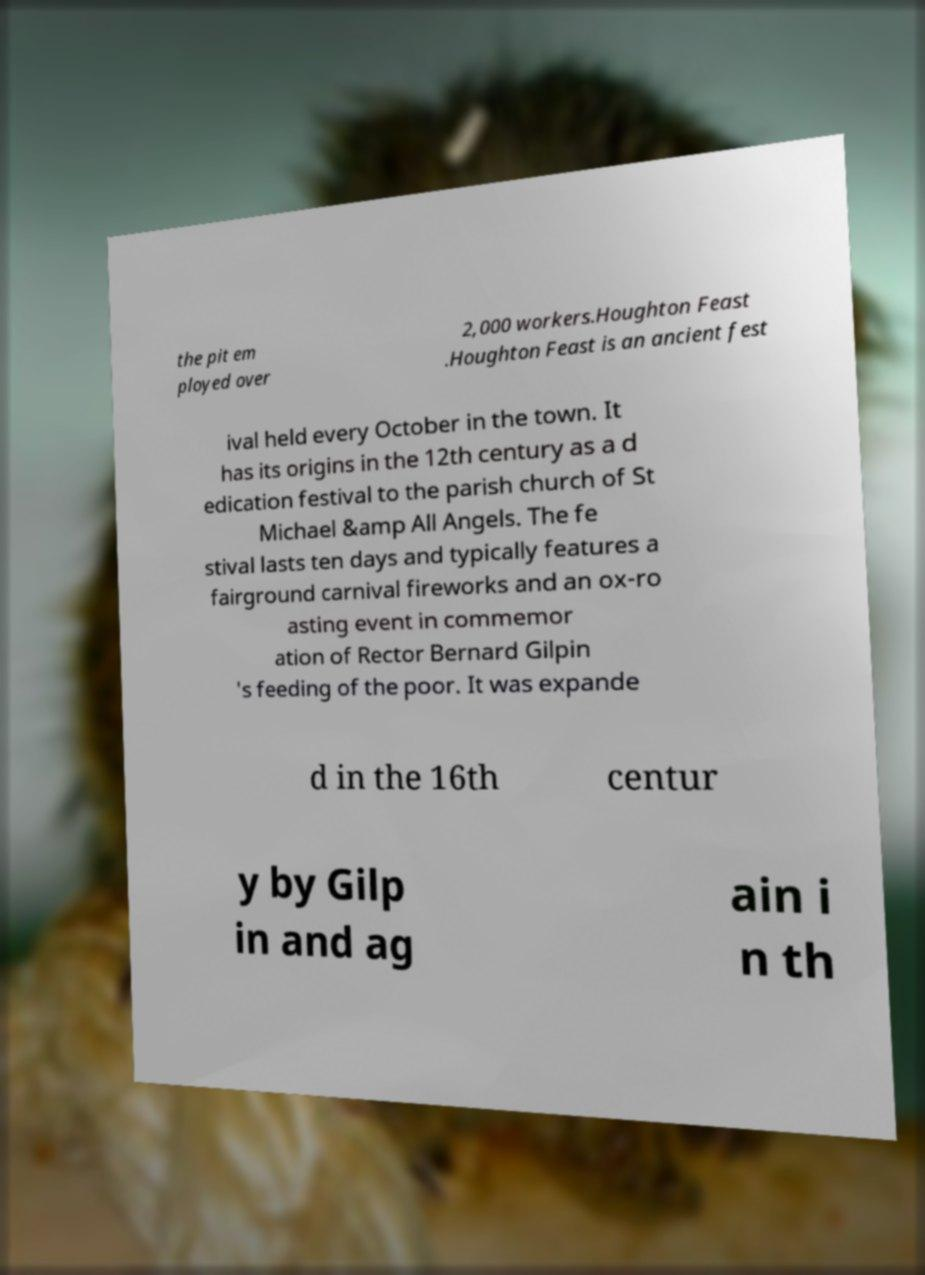For documentation purposes, I need the text within this image transcribed. Could you provide that? the pit em ployed over 2,000 workers.Houghton Feast .Houghton Feast is an ancient fest ival held every October in the town. It has its origins in the 12th century as a d edication festival to the parish church of St Michael &amp All Angels. The fe stival lasts ten days and typically features a fairground carnival fireworks and an ox-ro asting event in commemor ation of Rector Bernard Gilpin 's feeding of the poor. It was expande d in the 16th centur y by Gilp in and ag ain i n th 